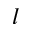<formula> <loc_0><loc_0><loc_500><loc_500>l</formula> 